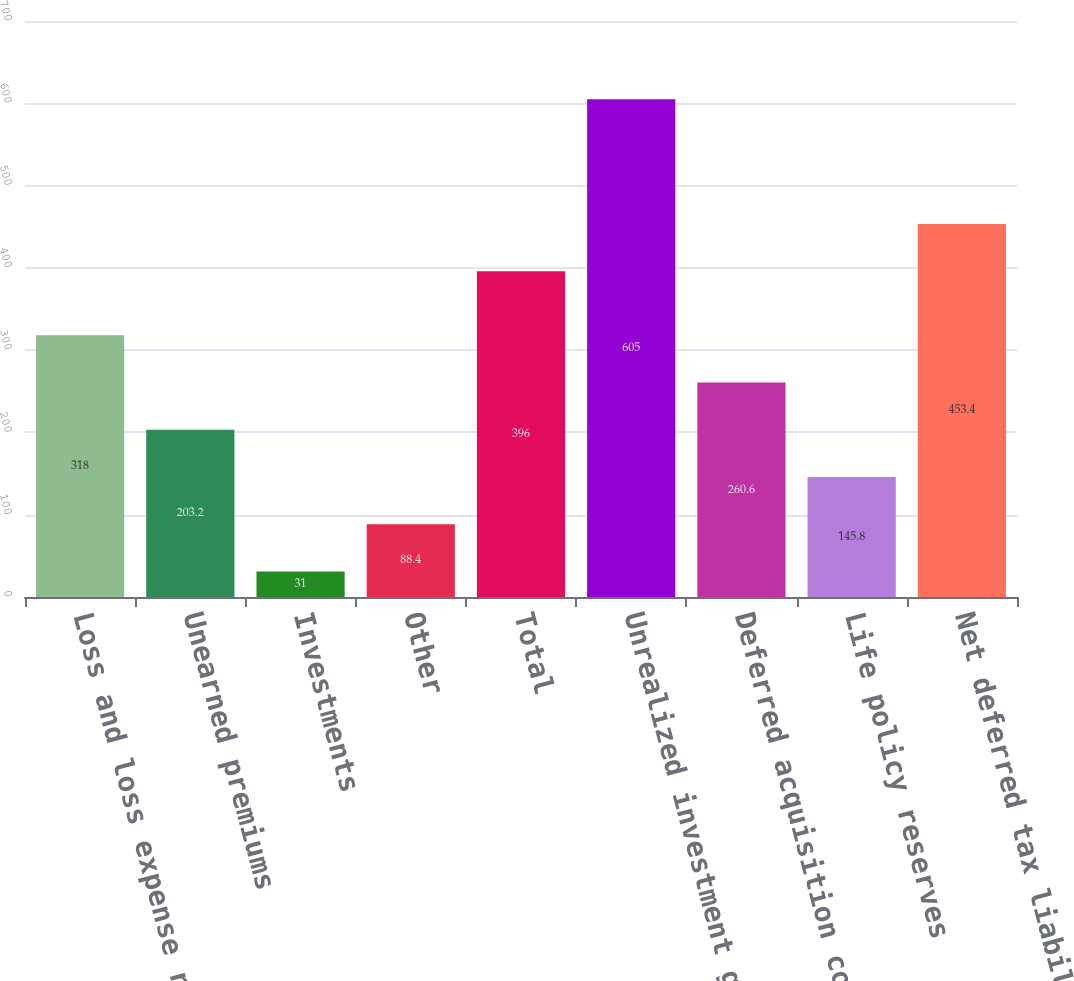<chart> <loc_0><loc_0><loc_500><loc_500><bar_chart><fcel>Loss and loss expense reserves<fcel>Unearned premiums<fcel>Investments<fcel>Other<fcel>Total<fcel>Unrealized investment gains<fcel>Deferred acquisition costs<fcel>Life policy reserves<fcel>Net deferred tax liability<nl><fcel>318<fcel>203.2<fcel>31<fcel>88.4<fcel>396<fcel>605<fcel>260.6<fcel>145.8<fcel>453.4<nl></chart> 